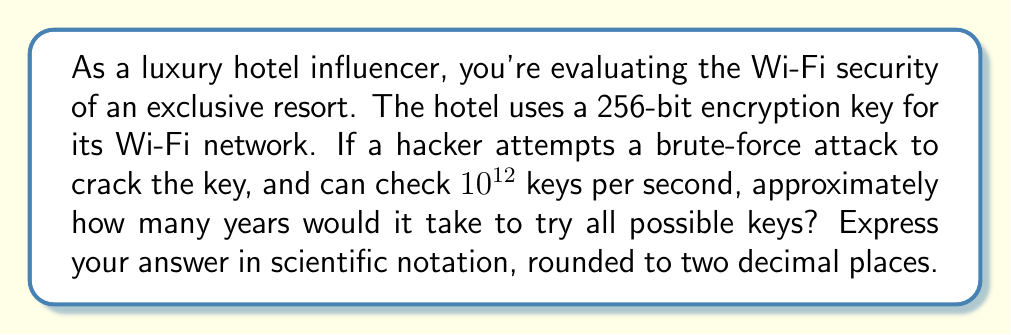Show me your answer to this math problem. Let's approach this step-by-step:

1) First, we need to calculate the total number of possible keys:
   For a 256-bit key, there are $2^{256}$ possible combinations.

2) Now, let's convert this to a decimal number:
   $2^{256} \approx 1.15792089 \times 10^{77}$ keys

3) The hacker can check $10^{12}$ keys per second. Let's calculate how many keys can be checked in a year:
   Keys per year = $10^{12} \times 60 \times 60 \times 24 \times 365.25$
                 = $3.15576 \times 10^{19}$ keys/year

4) Now, let's divide the total number of keys by the keys that can be checked per year:
   Years required = $\frac{1.15792089 \times 10^{77}}{3.15576 \times 10^{19}}$
                  = $3.66922 \times 10^{57}$ years

5) Rounding to two decimal places in scientific notation:
   $3.67 \times 10^{57}$ years

This demonstrates the extraordinary strength of a 256-bit encryption key, making it virtually unbreakable through brute-force methods with current technology.
Answer: $3.67 \times 10^{57}$ years 